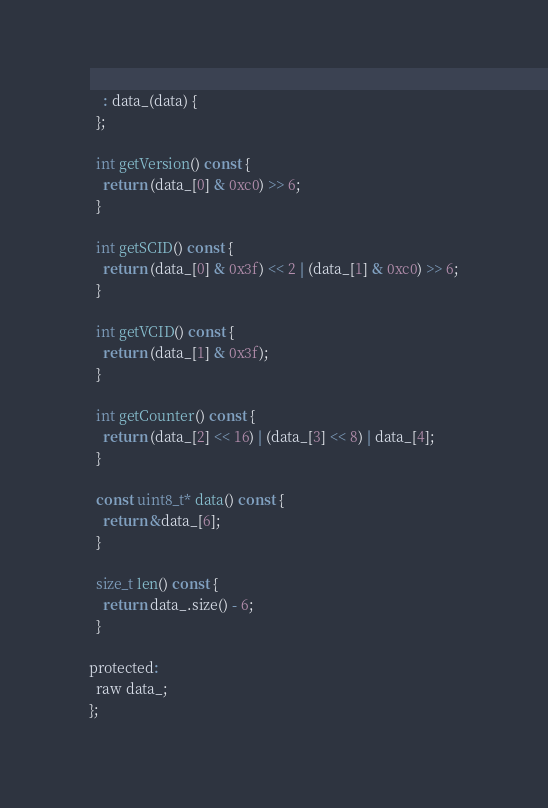Convert code to text. <code><loc_0><loc_0><loc_500><loc_500><_C_>    : data_(data) {
  };

  int getVersion() const {
    return (data_[0] & 0xc0) >> 6;
  }

  int getSCID() const {
    return (data_[0] & 0x3f) << 2 | (data_[1] & 0xc0) >> 6;
  }

  int getVCID() const {
    return (data_[1] & 0x3f);
  }

  int getCounter() const {
    return (data_[2] << 16) | (data_[3] << 8) | data_[4];
  }

  const uint8_t* data() const {
    return &data_[6];
  }

  size_t len() const {
    return data_.size() - 6;
  }

protected:
  raw data_;
};
</code> 